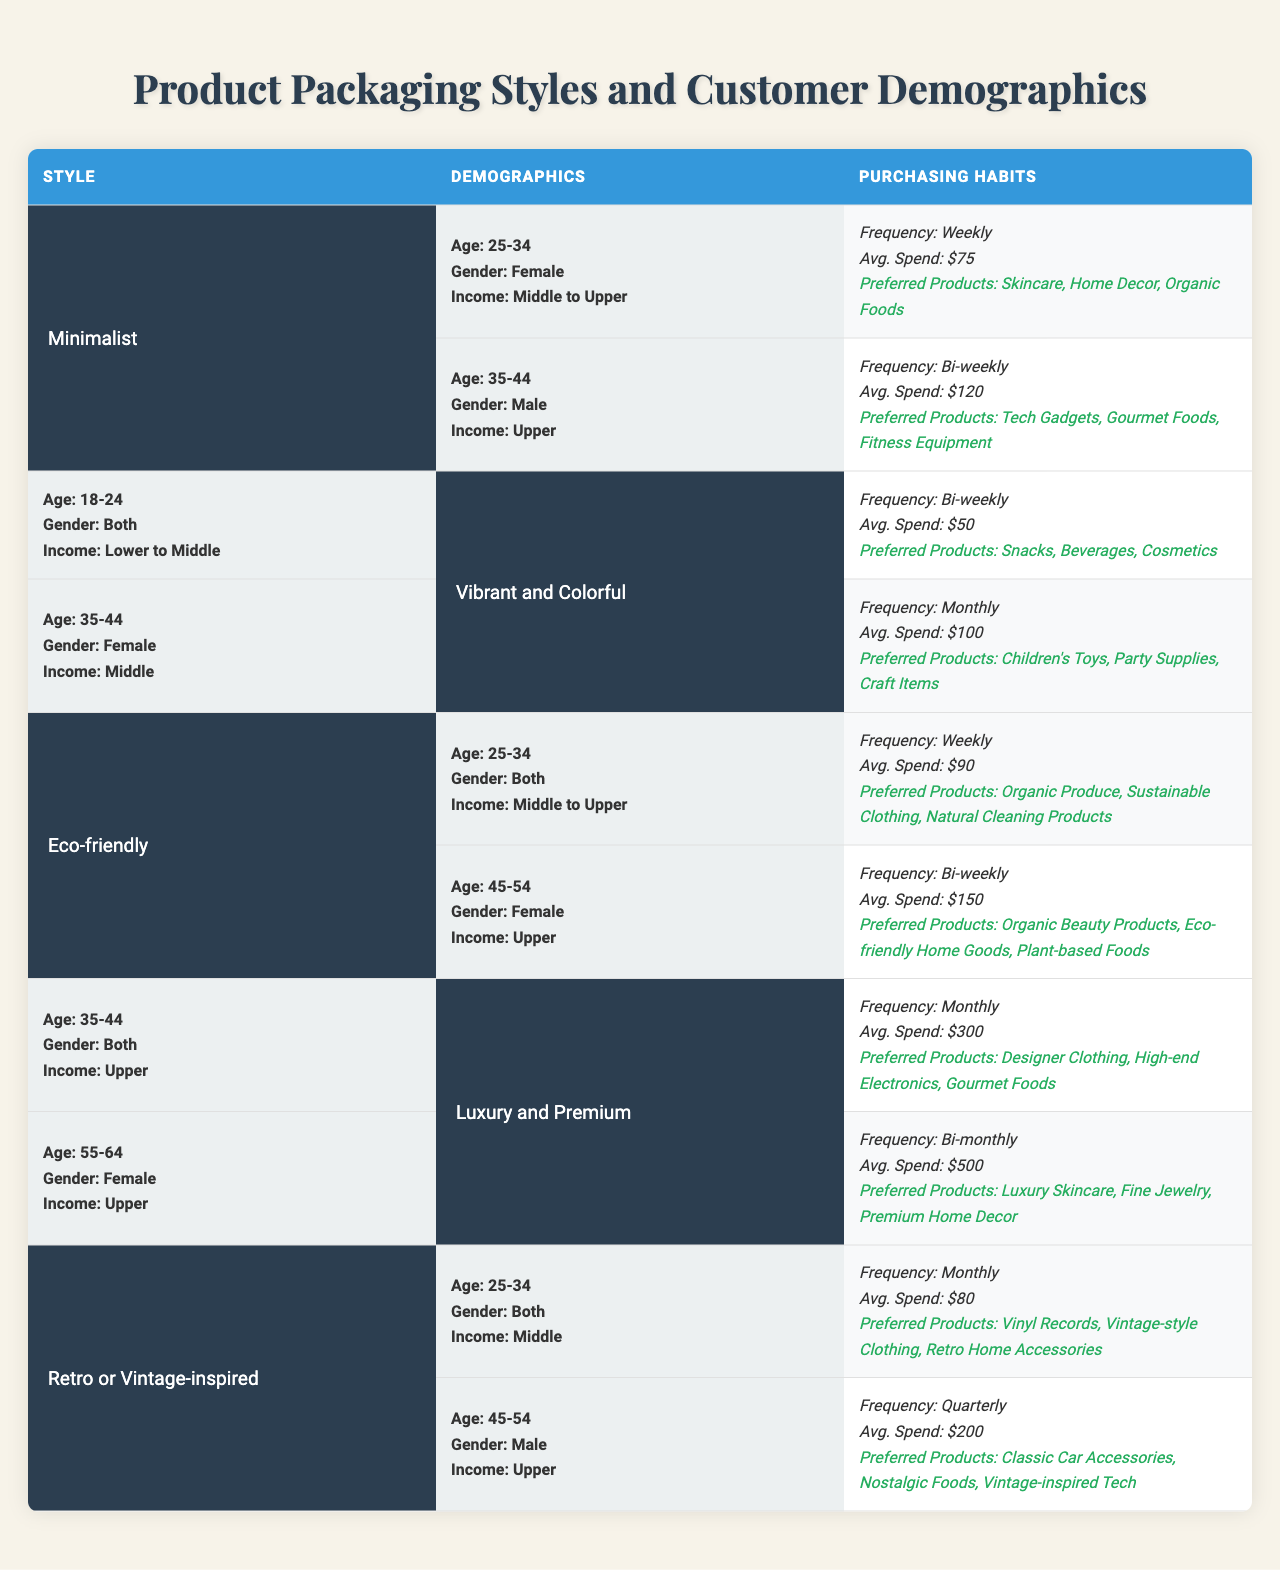What is the average spend for customers purchasing Eco-friendly products? For Eco-friendly products, the customers in the table mention two demographics: one spends $90 weekly and the other $150 bi-weekly. To find the average spend: (90 + 150) / 2 = 120.
Answer: $120 Which packaging style attracts customers aged 35-44? In the table, two styles listed include customers aged 35-44: Minimalist (Male) and Vibrant and Colorful (Female). Therefore, both these styles attract this age group.
Answer: Both Minimalist and Vibrant and Colorful What income level do customers prefer Luxury and Premium packaging styles? The table indicates that the customers interested in Luxury and Premium styles belong to the Upper income level.
Answer: Upper Do customers aged 18-24 prefer Minimalist packaging style? The data shows that customers aged 18-24 are associated with the Vibrant and Colorful style, not Minimalist. Hence, the answer is no.
Answer: No What is the purchasing frequency for Retro or Vintage-inspired packaging customers aged 25-34? For customers aged 25-34 interested in Retro or Vintage-inspired packaging, the purchasing frequency is monthly as stated in the respective demographic details.
Answer: Monthly How much do 45-54-year-old male customers spend on Retro or Vintage-inspired products? The table specifies that 45-54-year-old male customers spend $200 quarterly on Retro or Vintage-inspired products.
Answer: $200 Which age group spends the most on Luxury and Premium products? Among the Luxury and Premium customers, the 55-64 age group spends $500 bi-monthly while the 35-44 age group spends $300 monthly. To compare: $500 (bi-monthly) is greater than $300 (monthly).
Answer: 55-64 age group Is the average spend for Eco-friendly packaging higher than that for Vibrant and Colorful packaging? The average spend for Eco-friendly is $120 (from $90 and $150) and for Vibrant and Colorful, it is $75 (from $50 and $100). $120 is greater than $75. Therefore, the premise is true.
Answer: Yes What product category do both Male and Female customers aged 35-44 prefer under Minimalist and Vibrant and Colorful styles? For Minimalist, the preferred products are Tech Gadgets, Gourmet Foods, and Fitness Equipment; for Vibrant and Colorful, it’s Children's Toys, Party Supplies, and Craft Items. Both groups have distinct sets and do not overlap.
Answer: No overlap How many different preferred product categories do customers aged 25-34 exhibit across all packaging styles? The age group 25-34 appears in Minimalist (3 categories), Eco-friendly (3), and Retro or Vintage-inspired (3), totaling 9 different categories across these styles.
Answer: 9 categories 